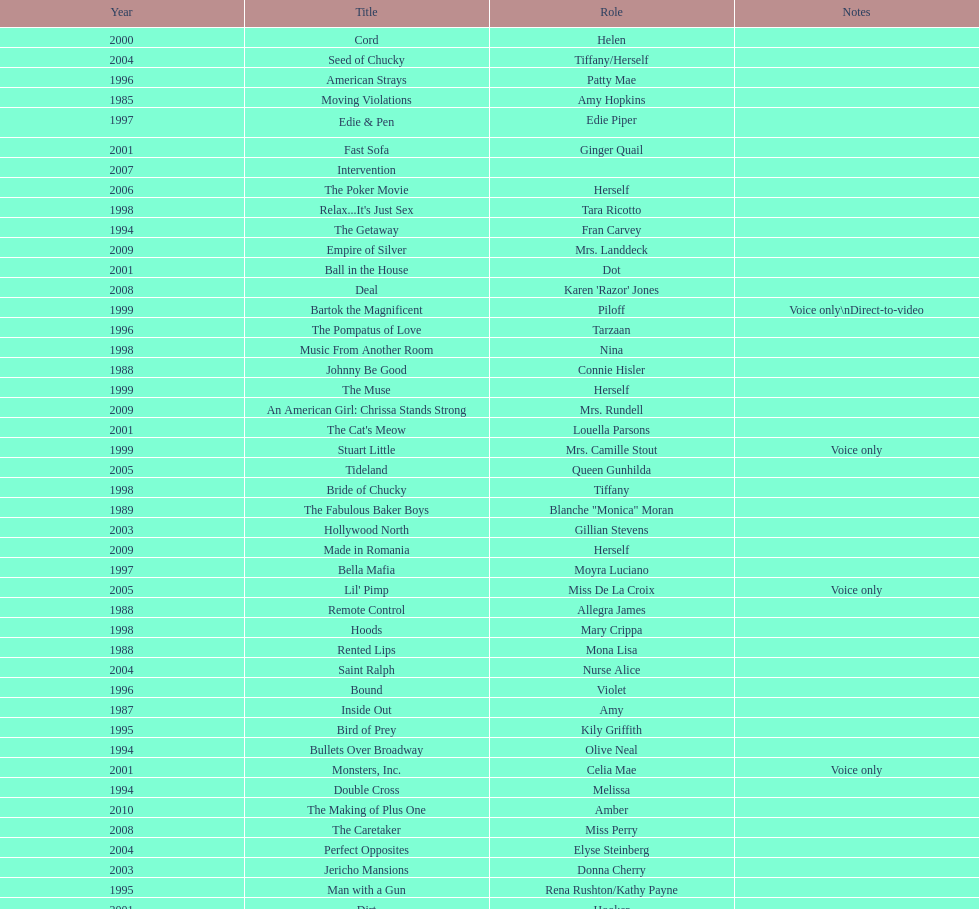Which film aired in 1994 and has marika as the role? Embrace of the Vampire. 